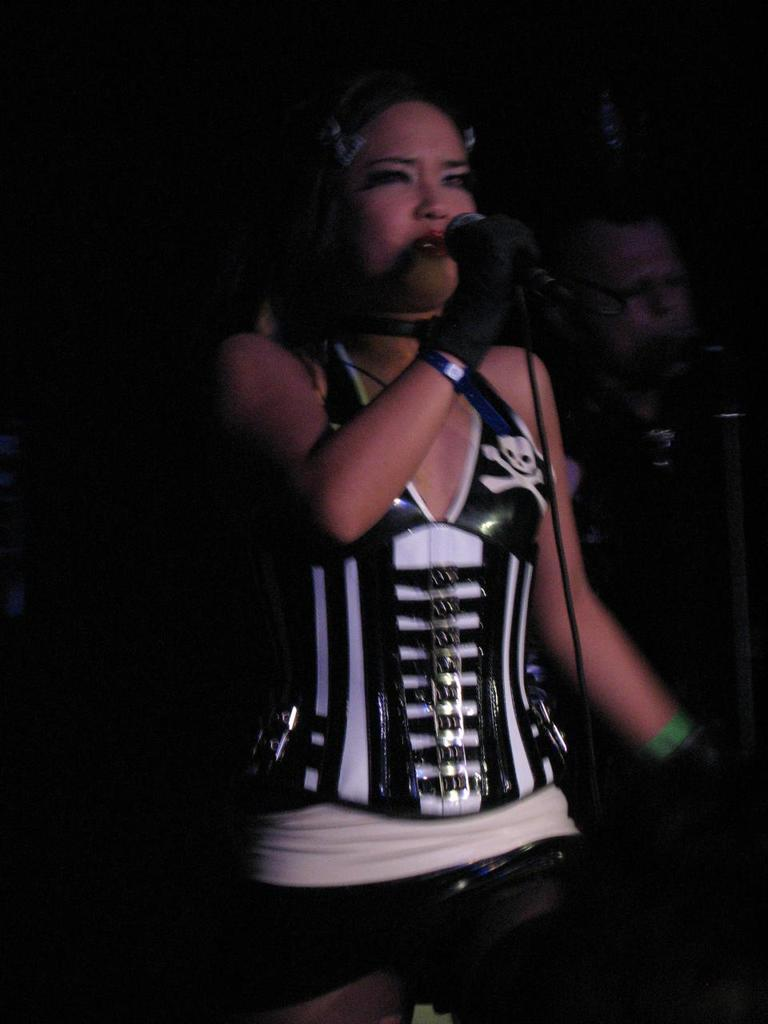Who is the main subject in the image? There is a lady in the image. What is the lady doing in the image? The lady is standing with a microphone in her hand and singing. Are there any other people in the image? Yes, there is a man in the image. What is the man doing in the image? The man is also singing with a microphone. What is the name of the road where the singing event is taking place in the image? There is no road visible in the image, and no information about the location of the singing event is provided. 